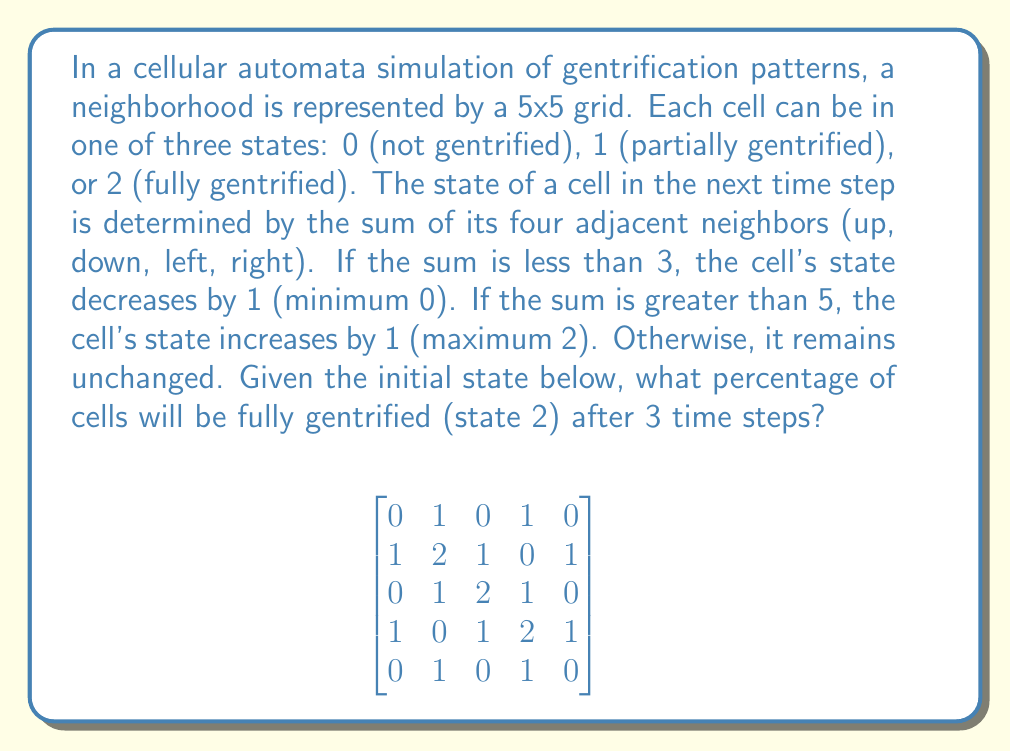Provide a solution to this math problem. Let's simulate the cellular automata step by step:

Step 1: Calculate the state after the first time step
- For each cell, sum the values of its four adjacent neighbors
- Apply the rules to determine the new state
- The resulting matrix after the first step:

$$
\begin{bmatrix}
1 & 1 & 1 & 1 & 1 \\
1 & 2 & 2 & 2 & 1 \\
1 & 2 & 2 & 2 & 1 \\
1 & 2 & 2 & 2 & 1 \\
1 & 1 & 1 & 1 & 1
\end{bmatrix}
$$

Step 2: Calculate the state after the second time step
- Repeat the process using the matrix from step 1
- The resulting matrix after the second step:

$$
\begin{bmatrix}
1 & 2 & 2 & 2 & 1 \\
2 & 2 & 2 & 2 & 2 \\
2 & 2 & 2 & 2 & 2 \\
2 & 2 & 2 & 2 & 2 \\
1 & 2 & 2 & 2 & 1
\end{bmatrix}
$$

Step 3: Calculate the state after the third time step
- Repeat the process using the matrix from step 2
- The final matrix after the third step:

$$
\begin{bmatrix}
2 & 2 & 2 & 2 & 2 \\
2 & 2 & 2 & 2 & 2 \\
2 & 2 & 2 & 2 & 2 \\
2 & 2 & 2 & 2 & 2 \\
2 & 2 & 2 & 2 & 2
\end{bmatrix}
$$

Step 4: Calculate the percentage of fully gentrified cells
- Count the number of cells with state 2: 25
- Total number of cells: 5 × 5 = 25
- Percentage: (25 / 25) × 100 = 100%
Answer: 100% 